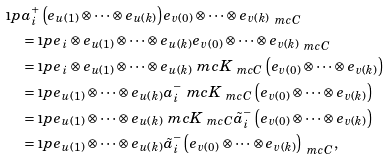<formula> <loc_0><loc_0><loc_500><loc_500>& \i p { a _ { i } ^ { + } \left ( e _ { u ( 1 ) } \otimes \dots \otimes e _ { u ( k ) } \right ) } { e _ { v ( 0 ) } \otimes \dots \otimes e _ { v ( k ) } } _ { \ m c { C } } \\ & \quad = \i p { e _ { i } \otimes e _ { u ( 1 ) } \otimes \dots \otimes e _ { u ( k ) } } { e _ { v ( 0 ) } \otimes \dots \otimes e _ { v ( k ) } } _ { \ m c { C } } \\ & \quad = \i p { e _ { i } \otimes e _ { u ( 1 ) } \otimes \dots \otimes e _ { u ( k ) } } { \ m c { K } _ { \ m c { C } } \left ( e _ { v ( 0 ) } \otimes \dots \otimes e _ { v ( k ) } \right ) } \\ & \quad = \i p { e _ { u ( 1 ) } \otimes \dots \otimes e _ { u ( k ) } } { a _ { i } ^ { - } \ m c { K } _ { \ m c { C } } \left ( e _ { v ( 0 ) } \otimes \dots \otimes e _ { v ( k ) } \right ) } \\ & \quad = \i p { e _ { u ( 1 ) } \otimes \dots \otimes e _ { u ( k ) } } { \ m c { K } _ { \ m c { C } } \tilde { a } _ { i } ^ { - } \left ( e _ { v ( 0 ) } \otimes \dots \otimes e _ { v ( k ) } \right ) } \\ & \quad = \i p { e _ { u ( 1 ) } \otimes \dots \otimes e _ { u ( k ) } } { \tilde { a } _ { i } ^ { - } \left ( e _ { v ( 0 ) } \otimes \dots \otimes e _ { v ( k ) } \right ) } _ { \ m c { C } } ,</formula> 